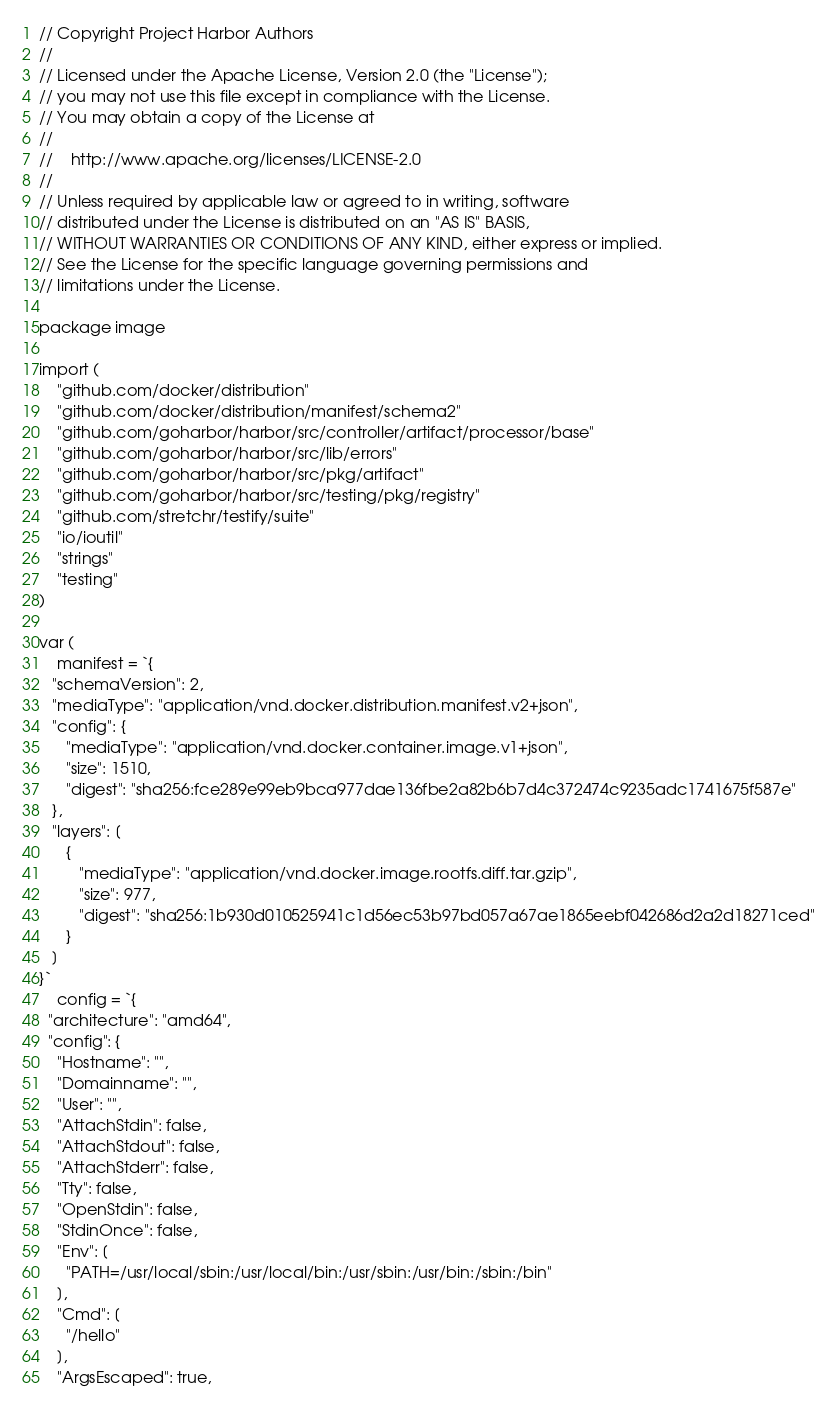Convert code to text. <code><loc_0><loc_0><loc_500><loc_500><_Go_>// Copyright Project Harbor Authors
//
// Licensed under the Apache License, Version 2.0 (the "License");
// you may not use this file except in compliance with the License.
// You may obtain a copy of the License at
//
//    http://www.apache.org/licenses/LICENSE-2.0
//
// Unless required by applicable law or agreed to in writing, software
// distributed under the License is distributed on an "AS IS" BASIS,
// WITHOUT WARRANTIES OR CONDITIONS OF ANY KIND, either express or implied.
// See the License for the specific language governing permissions and
// limitations under the License.

package image

import (
	"github.com/docker/distribution"
	"github.com/docker/distribution/manifest/schema2"
	"github.com/goharbor/harbor/src/controller/artifact/processor/base"
	"github.com/goharbor/harbor/src/lib/errors"
	"github.com/goharbor/harbor/src/pkg/artifact"
	"github.com/goharbor/harbor/src/testing/pkg/registry"
	"github.com/stretchr/testify/suite"
	"io/ioutil"
	"strings"
	"testing"
)

var (
	manifest = `{
   "schemaVersion": 2,
   "mediaType": "application/vnd.docker.distribution.manifest.v2+json",
   "config": {
      "mediaType": "application/vnd.docker.container.image.v1+json",
      "size": 1510,
      "digest": "sha256:fce289e99eb9bca977dae136fbe2a82b6b7d4c372474c9235adc1741675f587e"
   },
   "layers": [
      {
         "mediaType": "application/vnd.docker.image.rootfs.diff.tar.gzip",
         "size": 977,
         "digest": "sha256:1b930d010525941c1d56ec53b97bd057a67ae1865eebf042686d2a2d18271ced"
      }
   ]
}`
	config = `{
  "architecture": "amd64",
  "config": {
    "Hostname": "",
    "Domainname": "",
    "User": "",
    "AttachStdin": false,
    "AttachStdout": false,
    "AttachStderr": false,
    "Tty": false,
    "OpenStdin": false,
    "StdinOnce": false,
    "Env": [
      "PATH=/usr/local/sbin:/usr/local/bin:/usr/sbin:/usr/bin:/sbin:/bin"
    ],
    "Cmd": [
      "/hello"
    ],
    "ArgsEscaped": true,</code> 